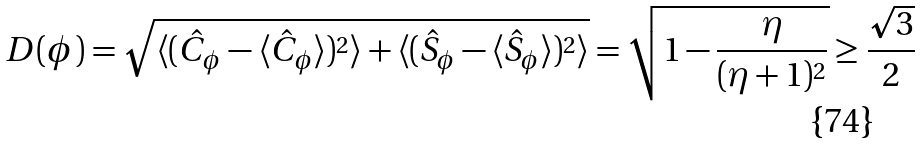Convert formula to latex. <formula><loc_0><loc_0><loc_500><loc_500>D ( \phi ) = \sqrt { \langle ( \hat { C } _ { \phi } - \langle \hat { C } _ { \phi } \rangle ) ^ { 2 } \rangle + \langle ( \hat { S } _ { \phi } - \langle \hat { S } _ { \phi } \rangle ) ^ { 2 } \rangle } = \sqrt { 1 - \frac { \eta } { ( \eta + 1 ) ^ { 2 } } } \geq \frac { \sqrt { 3 } } { 2 }</formula> 